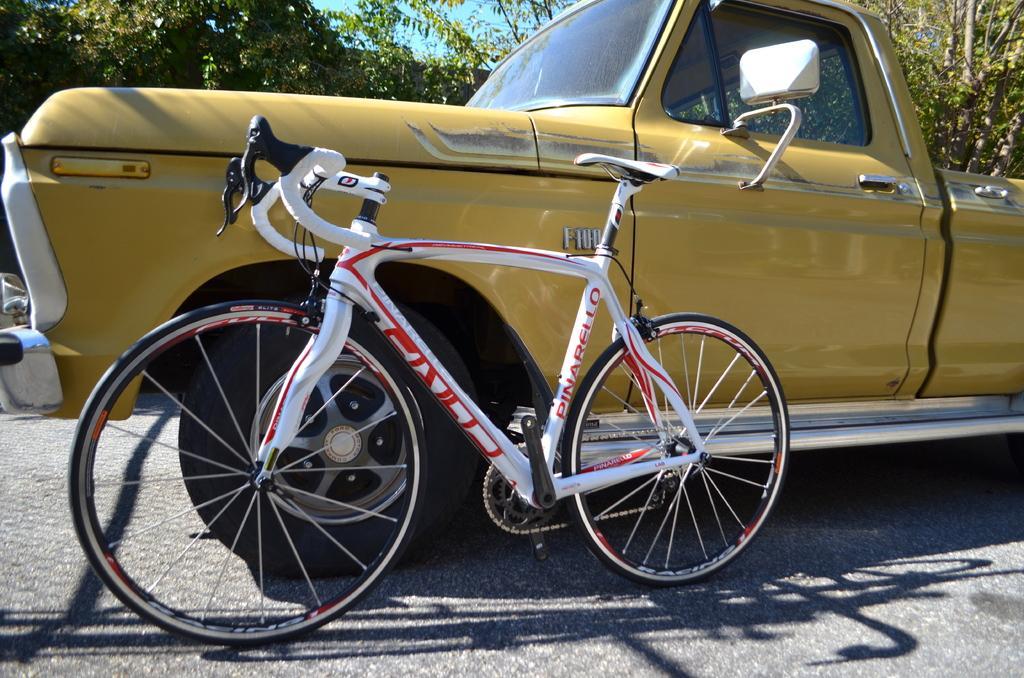In one or two sentences, can you explain what this image depicts? In this image we can see a car and a bicycle placed on the road. On the backside we can see some trees and the sky. 